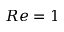<formula> <loc_0><loc_0><loc_500><loc_500>R e = 1</formula> 